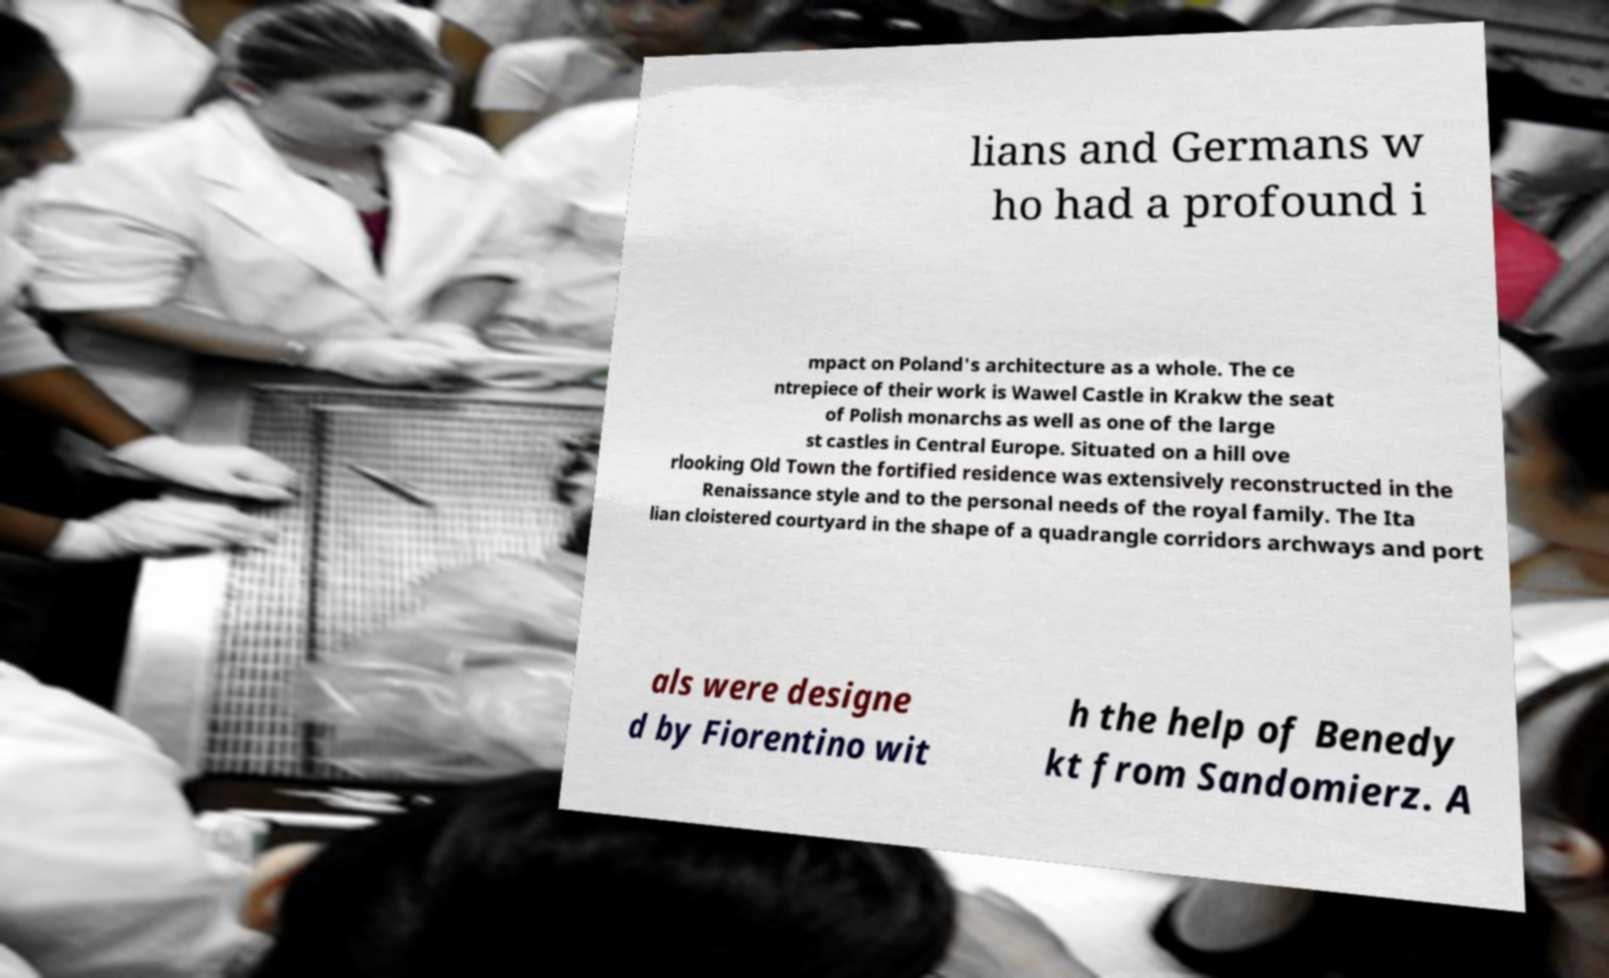Please identify and transcribe the text found in this image. lians and Germans w ho had a profound i mpact on Poland's architecture as a whole. The ce ntrepiece of their work is Wawel Castle in Krakw the seat of Polish monarchs as well as one of the large st castles in Central Europe. Situated on a hill ove rlooking Old Town the fortified residence was extensively reconstructed in the Renaissance style and to the personal needs of the royal family. The Ita lian cloistered courtyard in the shape of a quadrangle corridors archways and port als were designe d by Fiorentino wit h the help of Benedy kt from Sandomierz. A 